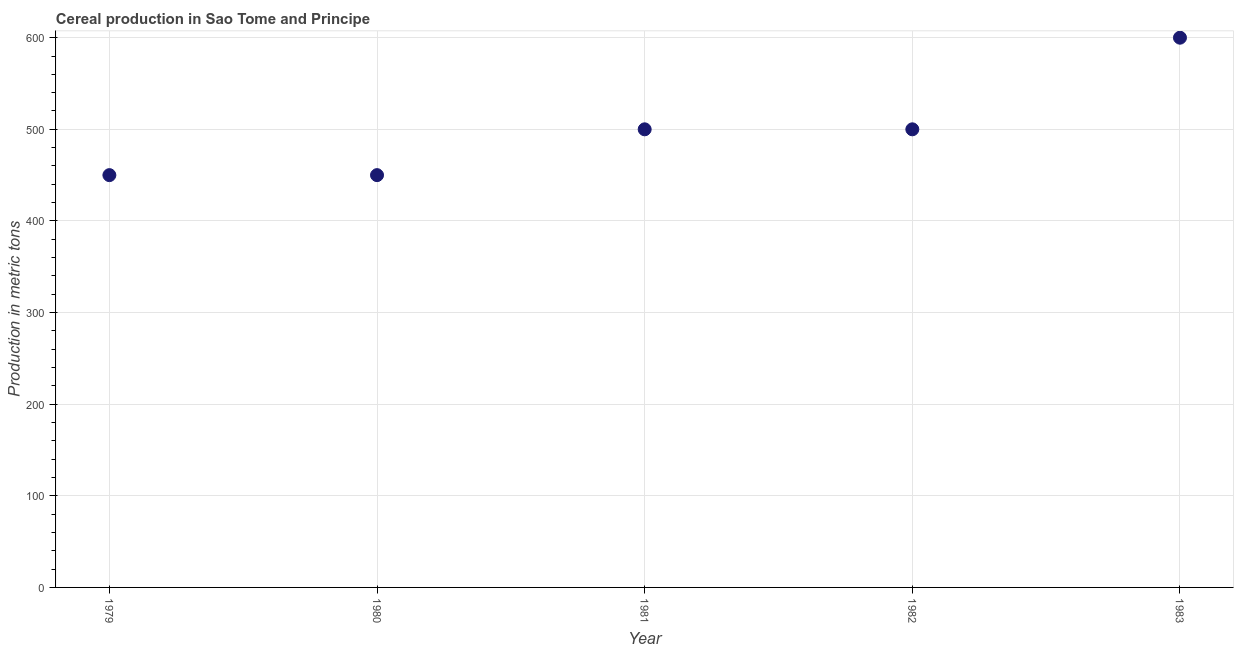What is the cereal production in 1980?
Offer a very short reply. 450. Across all years, what is the maximum cereal production?
Your answer should be very brief. 600. Across all years, what is the minimum cereal production?
Keep it short and to the point. 450. In which year was the cereal production minimum?
Provide a short and direct response. 1979. What is the sum of the cereal production?
Make the answer very short. 2500. What is the difference between the cereal production in 1980 and 1983?
Ensure brevity in your answer.  -150. What is the average cereal production per year?
Ensure brevity in your answer.  500. In how many years, is the cereal production greater than 180 metric tons?
Make the answer very short. 5. Do a majority of the years between 1979 and 1981 (inclusive) have cereal production greater than 440 metric tons?
Your answer should be compact. Yes. What is the ratio of the cereal production in 1982 to that in 1983?
Your answer should be very brief. 0.83. What is the difference between the highest and the second highest cereal production?
Provide a short and direct response. 100. What is the difference between the highest and the lowest cereal production?
Your response must be concise. 150. In how many years, is the cereal production greater than the average cereal production taken over all years?
Keep it short and to the point. 1. Does the cereal production monotonically increase over the years?
Ensure brevity in your answer.  No. How many dotlines are there?
Make the answer very short. 1. How many years are there in the graph?
Provide a short and direct response. 5. Are the values on the major ticks of Y-axis written in scientific E-notation?
Provide a succinct answer. No. What is the title of the graph?
Offer a very short reply. Cereal production in Sao Tome and Principe. What is the label or title of the Y-axis?
Offer a terse response. Production in metric tons. What is the Production in metric tons in 1979?
Ensure brevity in your answer.  450. What is the Production in metric tons in 1980?
Make the answer very short. 450. What is the Production in metric tons in 1982?
Your response must be concise. 500. What is the Production in metric tons in 1983?
Give a very brief answer. 600. What is the difference between the Production in metric tons in 1979 and 1982?
Ensure brevity in your answer.  -50. What is the difference between the Production in metric tons in 1979 and 1983?
Your answer should be compact. -150. What is the difference between the Production in metric tons in 1980 and 1981?
Keep it short and to the point. -50. What is the difference between the Production in metric tons in 1980 and 1982?
Offer a terse response. -50. What is the difference between the Production in metric tons in 1980 and 1983?
Your answer should be very brief. -150. What is the difference between the Production in metric tons in 1981 and 1982?
Ensure brevity in your answer.  0. What is the difference between the Production in metric tons in 1981 and 1983?
Give a very brief answer. -100. What is the difference between the Production in metric tons in 1982 and 1983?
Ensure brevity in your answer.  -100. What is the ratio of the Production in metric tons in 1979 to that in 1982?
Your answer should be very brief. 0.9. What is the ratio of the Production in metric tons in 1979 to that in 1983?
Your response must be concise. 0.75. What is the ratio of the Production in metric tons in 1980 to that in 1982?
Provide a succinct answer. 0.9. What is the ratio of the Production in metric tons in 1980 to that in 1983?
Offer a terse response. 0.75. What is the ratio of the Production in metric tons in 1981 to that in 1982?
Your response must be concise. 1. What is the ratio of the Production in metric tons in 1981 to that in 1983?
Ensure brevity in your answer.  0.83. What is the ratio of the Production in metric tons in 1982 to that in 1983?
Your answer should be very brief. 0.83. 